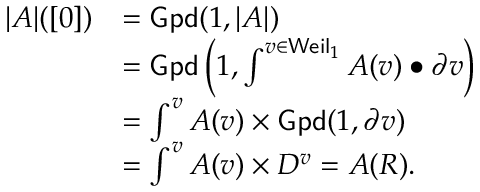<formula> <loc_0><loc_0><loc_500><loc_500>\begin{array} { r l } { | A | ( [ 0 ] ) } & { = G p d ( 1 , | A | ) } \\ & { = G p d \left ( 1 , \int ^ { v \in W e i l _ { 1 } } A ( v ) \bullet \partial v \right ) } \\ & { = \int ^ { v } A ( v ) \times G p d ( 1 , \partial v ) } \\ & { = \int ^ { v } A ( v ) \times D ^ { v } = A ( R ) . } \end{array}</formula> 